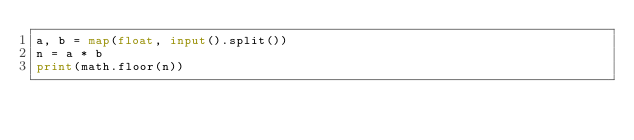Convert code to text. <code><loc_0><loc_0><loc_500><loc_500><_Python_>a, b = map(float, input().split())
n = a * b
print(math.floor(n))</code> 